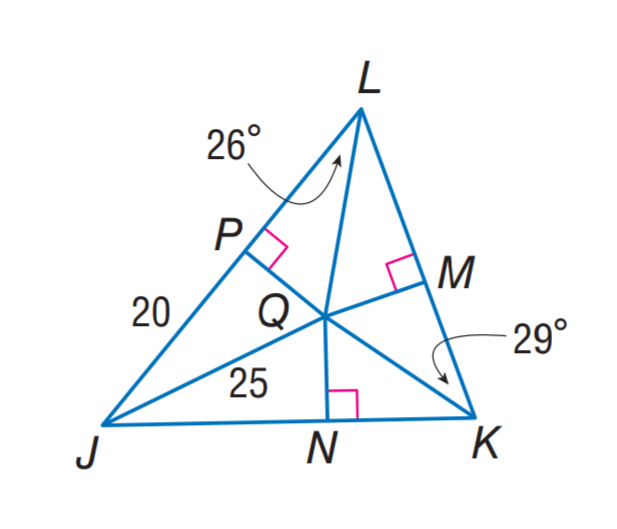Question: Q is the incenter of \triangle J K L. Find m \angle Q J K.
Choices:
A. 26
B. 29
C. 35
D. 70
Answer with the letter. Answer: C 